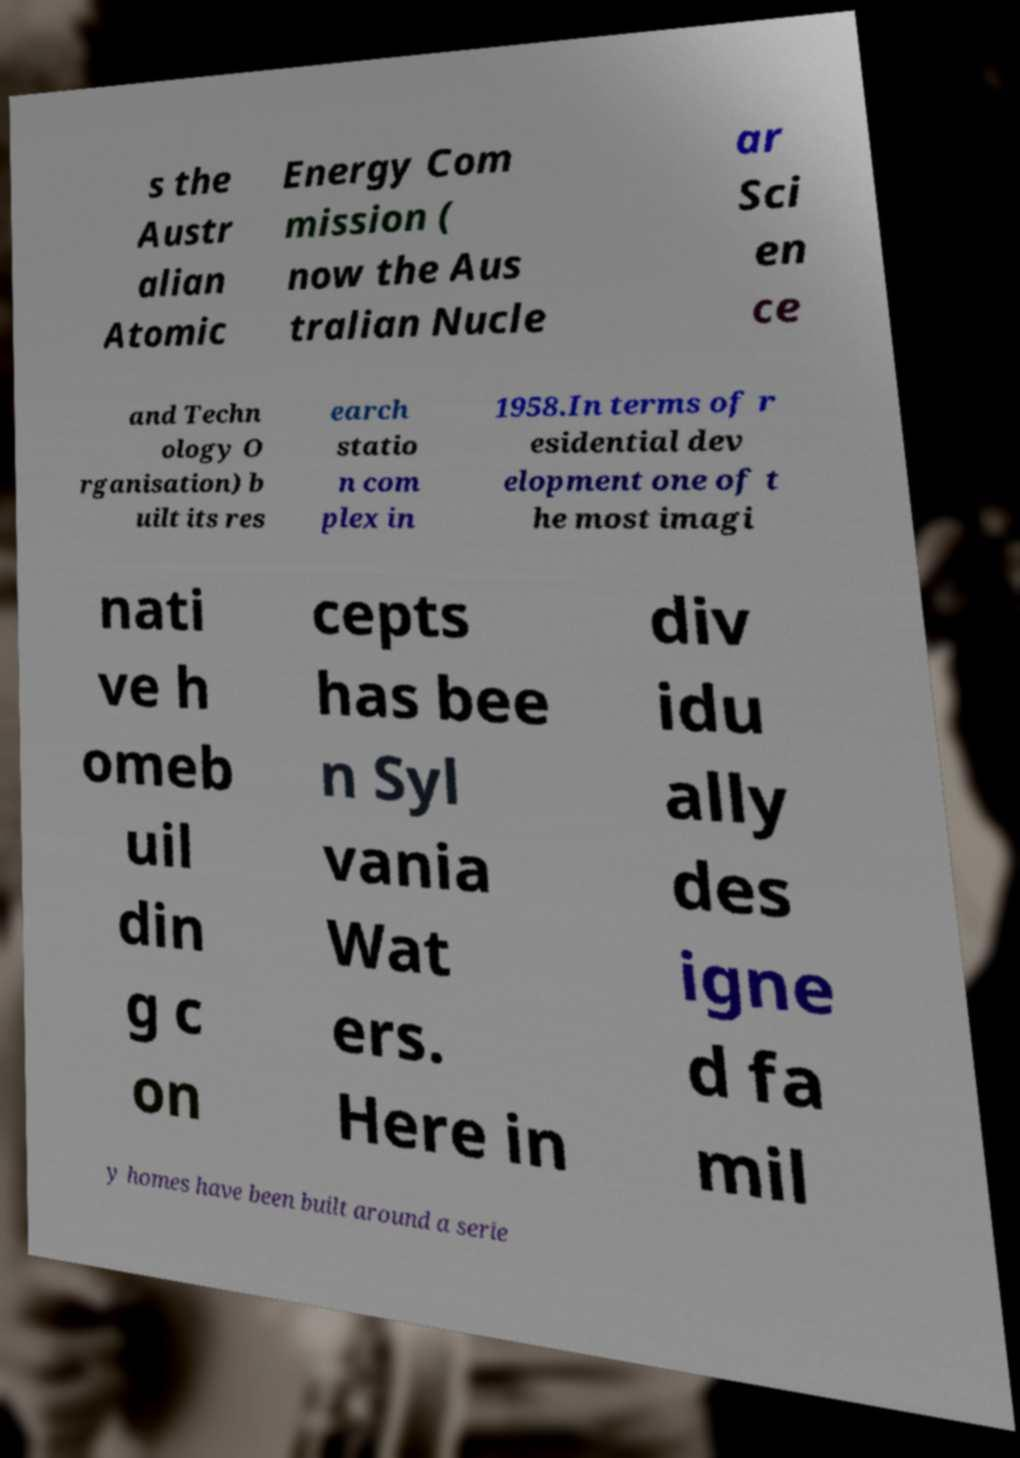Can you accurately transcribe the text from the provided image for me? s the Austr alian Atomic Energy Com mission ( now the Aus tralian Nucle ar Sci en ce and Techn ology O rganisation) b uilt its res earch statio n com plex in 1958.In terms of r esidential dev elopment one of t he most imagi nati ve h omeb uil din g c on cepts has bee n Syl vania Wat ers. Here in div idu ally des igne d fa mil y homes have been built around a serie 